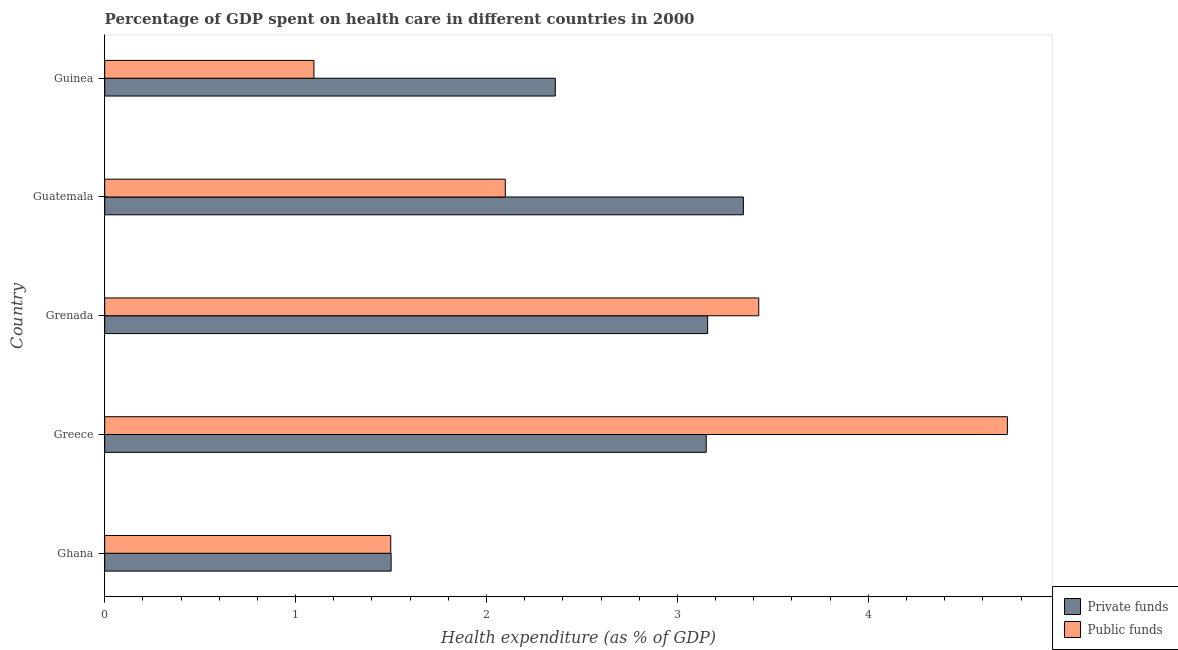Are the number of bars on each tick of the Y-axis equal?
Offer a terse response. Yes. What is the label of the 3rd group of bars from the top?
Provide a short and direct response. Grenada. What is the amount of private funds spent in healthcare in Ghana?
Give a very brief answer. 1.5. Across all countries, what is the maximum amount of public funds spent in healthcare?
Make the answer very short. 4.73. Across all countries, what is the minimum amount of public funds spent in healthcare?
Ensure brevity in your answer.  1.1. In which country was the amount of public funds spent in healthcare maximum?
Make the answer very short. Greece. In which country was the amount of private funds spent in healthcare minimum?
Make the answer very short. Ghana. What is the total amount of public funds spent in healthcare in the graph?
Ensure brevity in your answer.  12.85. What is the difference between the amount of public funds spent in healthcare in Ghana and that in Grenada?
Your response must be concise. -1.93. What is the difference between the amount of private funds spent in healthcare in Guatemala and the amount of public funds spent in healthcare in Ghana?
Give a very brief answer. 1.85. What is the average amount of public funds spent in healthcare per country?
Keep it short and to the point. 2.57. What is the difference between the amount of public funds spent in healthcare and amount of private funds spent in healthcare in Ghana?
Provide a succinct answer. -0. In how many countries, is the amount of private funds spent in healthcare greater than 3.6 %?
Keep it short and to the point. 0. What is the ratio of the amount of public funds spent in healthcare in Ghana to that in Guinea?
Provide a succinct answer. 1.37. Is the difference between the amount of private funds spent in healthcare in Ghana and Guinea greater than the difference between the amount of public funds spent in healthcare in Ghana and Guinea?
Offer a terse response. No. What is the difference between the highest and the second highest amount of public funds spent in healthcare?
Offer a terse response. 1.3. What is the difference between the highest and the lowest amount of private funds spent in healthcare?
Your response must be concise. 1.85. Is the sum of the amount of public funds spent in healthcare in Ghana and Greece greater than the maximum amount of private funds spent in healthcare across all countries?
Offer a terse response. Yes. What does the 1st bar from the top in Ghana represents?
Make the answer very short. Public funds. What does the 1st bar from the bottom in Grenada represents?
Your response must be concise. Private funds. How many countries are there in the graph?
Offer a very short reply. 5. Does the graph contain grids?
Provide a short and direct response. No. What is the title of the graph?
Your answer should be compact. Percentage of GDP spent on health care in different countries in 2000. What is the label or title of the X-axis?
Provide a short and direct response. Health expenditure (as % of GDP). What is the label or title of the Y-axis?
Make the answer very short. Country. What is the Health expenditure (as % of GDP) in Private funds in Ghana?
Provide a succinct answer. 1.5. What is the Health expenditure (as % of GDP) of Public funds in Ghana?
Make the answer very short. 1.5. What is the Health expenditure (as % of GDP) in Private funds in Greece?
Make the answer very short. 3.15. What is the Health expenditure (as % of GDP) of Public funds in Greece?
Keep it short and to the point. 4.73. What is the Health expenditure (as % of GDP) of Private funds in Grenada?
Offer a terse response. 3.16. What is the Health expenditure (as % of GDP) in Public funds in Grenada?
Your answer should be very brief. 3.43. What is the Health expenditure (as % of GDP) in Private funds in Guatemala?
Your response must be concise. 3.35. What is the Health expenditure (as % of GDP) of Public funds in Guatemala?
Make the answer very short. 2.1. What is the Health expenditure (as % of GDP) of Private funds in Guinea?
Your response must be concise. 2.36. What is the Health expenditure (as % of GDP) in Public funds in Guinea?
Offer a very short reply. 1.1. Across all countries, what is the maximum Health expenditure (as % of GDP) of Private funds?
Keep it short and to the point. 3.35. Across all countries, what is the maximum Health expenditure (as % of GDP) in Public funds?
Provide a succinct answer. 4.73. Across all countries, what is the minimum Health expenditure (as % of GDP) in Private funds?
Offer a terse response. 1.5. Across all countries, what is the minimum Health expenditure (as % of GDP) in Public funds?
Provide a short and direct response. 1.1. What is the total Health expenditure (as % of GDP) in Private funds in the graph?
Make the answer very short. 13.52. What is the total Health expenditure (as % of GDP) of Public funds in the graph?
Your answer should be compact. 12.85. What is the difference between the Health expenditure (as % of GDP) of Private funds in Ghana and that in Greece?
Offer a terse response. -1.65. What is the difference between the Health expenditure (as % of GDP) in Public funds in Ghana and that in Greece?
Make the answer very short. -3.23. What is the difference between the Health expenditure (as % of GDP) in Private funds in Ghana and that in Grenada?
Your response must be concise. -1.66. What is the difference between the Health expenditure (as % of GDP) in Public funds in Ghana and that in Grenada?
Keep it short and to the point. -1.93. What is the difference between the Health expenditure (as % of GDP) of Private funds in Ghana and that in Guatemala?
Offer a terse response. -1.85. What is the difference between the Health expenditure (as % of GDP) of Public funds in Ghana and that in Guatemala?
Make the answer very short. -0.6. What is the difference between the Health expenditure (as % of GDP) of Private funds in Ghana and that in Guinea?
Provide a short and direct response. -0.86. What is the difference between the Health expenditure (as % of GDP) of Public funds in Ghana and that in Guinea?
Offer a terse response. 0.4. What is the difference between the Health expenditure (as % of GDP) of Private funds in Greece and that in Grenada?
Your answer should be very brief. -0.01. What is the difference between the Health expenditure (as % of GDP) in Public funds in Greece and that in Grenada?
Offer a terse response. 1.3. What is the difference between the Health expenditure (as % of GDP) in Private funds in Greece and that in Guatemala?
Your answer should be compact. -0.19. What is the difference between the Health expenditure (as % of GDP) in Public funds in Greece and that in Guatemala?
Give a very brief answer. 2.63. What is the difference between the Health expenditure (as % of GDP) in Private funds in Greece and that in Guinea?
Provide a short and direct response. 0.79. What is the difference between the Health expenditure (as % of GDP) of Public funds in Greece and that in Guinea?
Give a very brief answer. 3.63. What is the difference between the Health expenditure (as % of GDP) of Private funds in Grenada and that in Guatemala?
Offer a terse response. -0.19. What is the difference between the Health expenditure (as % of GDP) in Public funds in Grenada and that in Guatemala?
Ensure brevity in your answer.  1.33. What is the difference between the Health expenditure (as % of GDP) in Private funds in Grenada and that in Guinea?
Provide a succinct answer. 0.8. What is the difference between the Health expenditure (as % of GDP) in Public funds in Grenada and that in Guinea?
Make the answer very short. 2.33. What is the difference between the Health expenditure (as % of GDP) in Private funds in Guatemala and that in Guinea?
Your answer should be compact. 0.99. What is the difference between the Health expenditure (as % of GDP) in Public funds in Guatemala and that in Guinea?
Your answer should be compact. 1. What is the difference between the Health expenditure (as % of GDP) of Private funds in Ghana and the Health expenditure (as % of GDP) of Public funds in Greece?
Make the answer very short. -3.23. What is the difference between the Health expenditure (as % of GDP) of Private funds in Ghana and the Health expenditure (as % of GDP) of Public funds in Grenada?
Keep it short and to the point. -1.93. What is the difference between the Health expenditure (as % of GDP) in Private funds in Ghana and the Health expenditure (as % of GDP) in Public funds in Guatemala?
Ensure brevity in your answer.  -0.6. What is the difference between the Health expenditure (as % of GDP) in Private funds in Ghana and the Health expenditure (as % of GDP) in Public funds in Guinea?
Ensure brevity in your answer.  0.4. What is the difference between the Health expenditure (as % of GDP) in Private funds in Greece and the Health expenditure (as % of GDP) in Public funds in Grenada?
Your response must be concise. -0.28. What is the difference between the Health expenditure (as % of GDP) of Private funds in Greece and the Health expenditure (as % of GDP) of Public funds in Guatemala?
Offer a terse response. 1.05. What is the difference between the Health expenditure (as % of GDP) in Private funds in Greece and the Health expenditure (as % of GDP) in Public funds in Guinea?
Your answer should be compact. 2.05. What is the difference between the Health expenditure (as % of GDP) in Private funds in Grenada and the Health expenditure (as % of GDP) in Public funds in Guatemala?
Your answer should be compact. 1.06. What is the difference between the Health expenditure (as % of GDP) of Private funds in Grenada and the Health expenditure (as % of GDP) of Public funds in Guinea?
Offer a very short reply. 2.06. What is the difference between the Health expenditure (as % of GDP) in Private funds in Guatemala and the Health expenditure (as % of GDP) in Public funds in Guinea?
Your answer should be compact. 2.25. What is the average Health expenditure (as % of GDP) of Private funds per country?
Your answer should be compact. 2.7. What is the average Health expenditure (as % of GDP) of Public funds per country?
Offer a terse response. 2.57. What is the difference between the Health expenditure (as % of GDP) of Private funds and Health expenditure (as % of GDP) of Public funds in Ghana?
Provide a short and direct response. 0. What is the difference between the Health expenditure (as % of GDP) in Private funds and Health expenditure (as % of GDP) in Public funds in Greece?
Your response must be concise. -1.58. What is the difference between the Health expenditure (as % of GDP) in Private funds and Health expenditure (as % of GDP) in Public funds in Grenada?
Ensure brevity in your answer.  -0.27. What is the difference between the Health expenditure (as % of GDP) in Private funds and Health expenditure (as % of GDP) in Public funds in Guatemala?
Give a very brief answer. 1.25. What is the difference between the Health expenditure (as % of GDP) in Private funds and Health expenditure (as % of GDP) in Public funds in Guinea?
Ensure brevity in your answer.  1.26. What is the ratio of the Health expenditure (as % of GDP) in Private funds in Ghana to that in Greece?
Provide a short and direct response. 0.48. What is the ratio of the Health expenditure (as % of GDP) of Public funds in Ghana to that in Greece?
Keep it short and to the point. 0.32. What is the ratio of the Health expenditure (as % of GDP) of Private funds in Ghana to that in Grenada?
Ensure brevity in your answer.  0.47. What is the ratio of the Health expenditure (as % of GDP) in Public funds in Ghana to that in Grenada?
Keep it short and to the point. 0.44. What is the ratio of the Health expenditure (as % of GDP) in Private funds in Ghana to that in Guatemala?
Your answer should be very brief. 0.45. What is the ratio of the Health expenditure (as % of GDP) of Public funds in Ghana to that in Guatemala?
Offer a terse response. 0.71. What is the ratio of the Health expenditure (as % of GDP) in Private funds in Ghana to that in Guinea?
Give a very brief answer. 0.64. What is the ratio of the Health expenditure (as % of GDP) of Public funds in Ghana to that in Guinea?
Ensure brevity in your answer.  1.37. What is the ratio of the Health expenditure (as % of GDP) of Private funds in Greece to that in Grenada?
Provide a short and direct response. 1. What is the ratio of the Health expenditure (as % of GDP) in Public funds in Greece to that in Grenada?
Provide a short and direct response. 1.38. What is the ratio of the Health expenditure (as % of GDP) of Private funds in Greece to that in Guatemala?
Provide a short and direct response. 0.94. What is the ratio of the Health expenditure (as % of GDP) in Public funds in Greece to that in Guatemala?
Ensure brevity in your answer.  2.25. What is the ratio of the Health expenditure (as % of GDP) in Private funds in Greece to that in Guinea?
Make the answer very short. 1.33. What is the ratio of the Health expenditure (as % of GDP) in Public funds in Greece to that in Guinea?
Your answer should be compact. 4.31. What is the ratio of the Health expenditure (as % of GDP) in Private funds in Grenada to that in Guatemala?
Provide a succinct answer. 0.94. What is the ratio of the Health expenditure (as % of GDP) in Public funds in Grenada to that in Guatemala?
Offer a terse response. 1.63. What is the ratio of the Health expenditure (as % of GDP) in Private funds in Grenada to that in Guinea?
Provide a succinct answer. 1.34. What is the ratio of the Health expenditure (as % of GDP) of Public funds in Grenada to that in Guinea?
Keep it short and to the point. 3.13. What is the ratio of the Health expenditure (as % of GDP) in Private funds in Guatemala to that in Guinea?
Provide a short and direct response. 1.42. What is the ratio of the Health expenditure (as % of GDP) in Public funds in Guatemala to that in Guinea?
Make the answer very short. 1.91. What is the difference between the highest and the second highest Health expenditure (as % of GDP) in Private funds?
Provide a short and direct response. 0.19. What is the difference between the highest and the second highest Health expenditure (as % of GDP) in Public funds?
Provide a short and direct response. 1.3. What is the difference between the highest and the lowest Health expenditure (as % of GDP) of Private funds?
Ensure brevity in your answer.  1.85. What is the difference between the highest and the lowest Health expenditure (as % of GDP) of Public funds?
Provide a succinct answer. 3.63. 